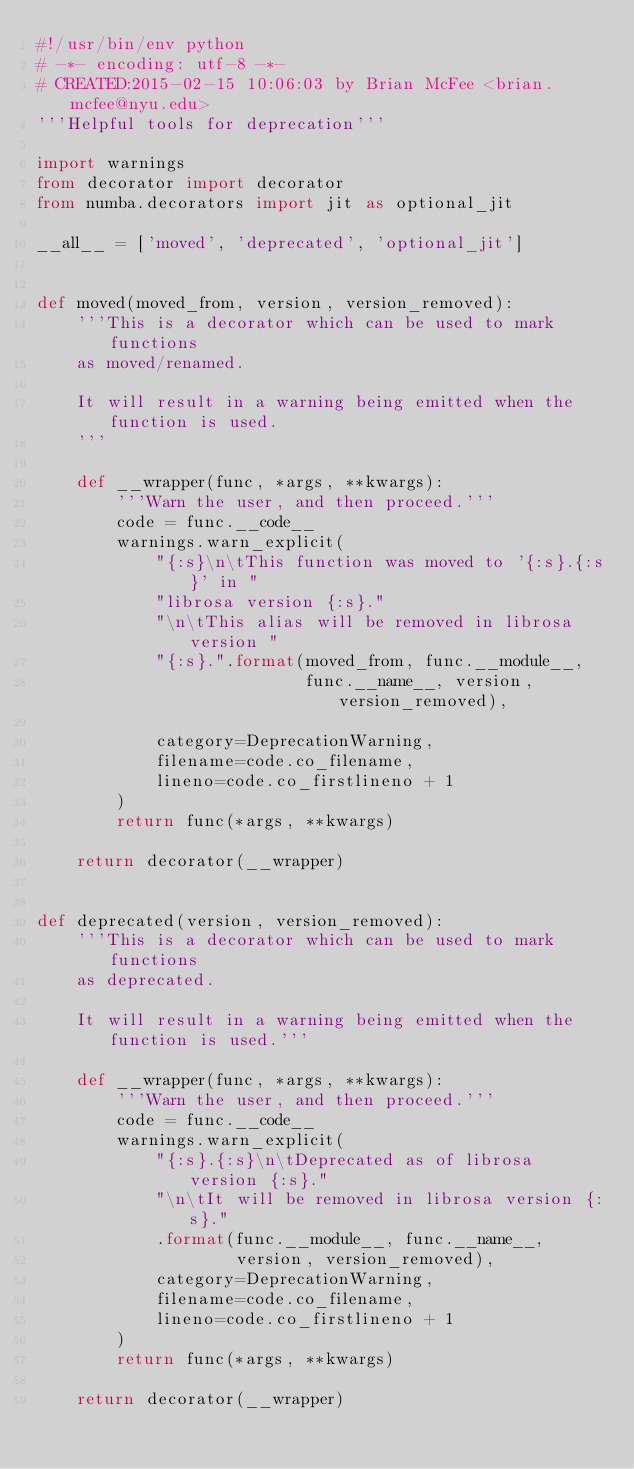Convert code to text. <code><loc_0><loc_0><loc_500><loc_500><_Python_>#!/usr/bin/env python
# -*- encoding: utf-8 -*-
# CREATED:2015-02-15 10:06:03 by Brian McFee <brian.mcfee@nyu.edu>
'''Helpful tools for deprecation'''

import warnings
from decorator import decorator
from numba.decorators import jit as optional_jit

__all__ = ['moved', 'deprecated', 'optional_jit']


def moved(moved_from, version, version_removed):
    '''This is a decorator which can be used to mark functions
    as moved/renamed.

    It will result in a warning being emitted when the function is used.
    '''

    def __wrapper(func, *args, **kwargs):
        '''Warn the user, and then proceed.'''
        code = func.__code__
        warnings.warn_explicit(
            "{:s}\n\tThis function was moved to '{:s}.{:s}' in "
            "librosa version {:s}."
            "\n\tThis alias will be removed in librosa version "
            "{:s}.".format(moved_from, func.__module__,
                           func.__name__, version, version_removed),

            category=DeprecationWarning,
            filename=code.co_filename,
            lineno=code.co_firstlineno + 1
        )
        return func(*args, **kwargs)

    return decorator(__wrapper)


def deprecated(version, version_removed):
    '''This is a decorator which can be used to mark functions
    as deprecated.

    It will result in a warning being emitted when the function is used.'''

    def __wrapper(func, *args, **kwargs):
        '''Warn the user, and then proceed.'''
        code = func.__code__
        warnings.warn_explicit(
            "{:s}.{:s}\n\tDeprecated as of librosa version {:s}."
            "\n\tIt will be removed in librosa version {:s}."
            .format(func.__module__, func.__name__,
                    version, version_removed),
            category=DeprecationWarning,
            filename=code.co_filename,
            lineno=code.co_firstlineno + 1
        )
        return func(*args, **kwargs)

    return decorator(__wrapper)
</code> 